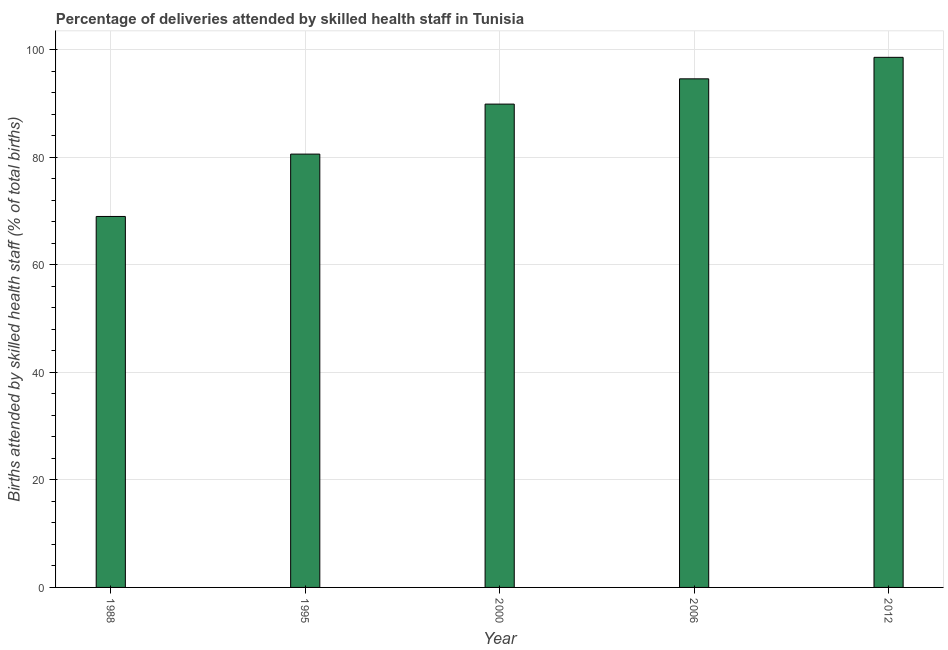What is the title of the graph?
Your answer should be very brief. Percentage of deliveries attended by skilled health staff in Tunisia. What is the label or title of the X-axis?
Your response must be concise. Year. What is the label or title of the Y-axis?
Ensure brevity in your answer.  Births attended by skilled health staff (% of total births). What is the number of births attended by skilled health staff in 2000?
Offer a terse response. 89.9. Across all years, what is the maximum number of births attended by skilled health staff?
Your response must be concise. 98.6. Across all years, what is the minimum number of births attended by skilled health staff?
Your response must be concise. 69. What is the sum of the number of births attended by skilled health staff?
Your answer should be very brief. 432.7. What is the difference between the number of births attended by skilled health staff in 1988 and 2000?
Make the answer very short. -20.9. What is the average number of births attended by skilled health staff per year?
Give a very brief answer. 86.54. What is the median number of births attended by skilled health staff?
Provide a succinct answer. 89.9. In how many years, is the number of births attended by skilled health staff greater than 32 %?
Your answer should be compact. 5. What is the ratio of the number of births attended by skilled health staff in 1988 to that in 2000?
Your answer should be very brief. 0.77. What is the difference between the highest and the second highest number of births attended by skilled health staff?
Your answer should be very brief. 4. Is the sum of the number of births attended by skilled health staff in 1995 and 2006 greater than the maximum number of births attended by skilled health staff across all years?
Your answer should be compact. Yes. What is the difference between the highest and the lowest number of births attended by skilled health staff?
Ensure brevity in your answer.  29.6. How many bars are there?
Provide a short and direct response. 5. How many years are there in the graph?
Offer a very short reply. 5. What is the Births attended by skilled health staff (% of total births) of 1995?
Give a very brief answer. 80.6. What is the Births attended by skilled health staff (% of total births) in 2000?
Keep it short and to the point. 89.9. What is the Births attended by skilled health staff (% of total births) in 2006?
Your response must be concise. 94.6. What is the Births attended by skilled health staff (% of total births) in 2012?
Your answer should be very brief. 98.6. What is the difference between the Births attended by skilled health staff (% of total births) in 1988 and 1995?
Your answer should be compact. -11.6. What is the difference between the Births attended by skilled health staff (% of total births) in 1988 and 2000?
Give a very brief answer. -20.9. What is the difference between the Births attended by skilled health staff (% of total births) in 1988 and 2006?
Ensure brevity in your answer.  -25.6. What is the difference between the Births attended by skilled health staff (% of total births) in 1988 and 2012?
Give a very brief answer. -29.6. What is the difference between the Births attended by skilled health staff (% of total births) in 1995 and 2012?
Offer a very short reply. -18. What is the ratio of the Births attended by skilled health staff (% of total births) in 1988 to that in 1995?
Your answer should be very brief. 0.86. What is the ratio of the Births attended by skilled health staff (% of total births) in 1988 to that in 2000?
Provide a succinct answer. 0.77. What is the ratio of the Births attended by skilled health staff (% of total births) in 1988 to that in 2006?
Ensure brevity in your answer.  0.73. What is the ratio of the Births attended by skilled health staff (% of total births) in 1995 to that in 2000?
Your answer should be compact. 0.9. What is the ratio of the Births attended by skilled health staff (% of total births) in 1995 to that in 2006?
Offer a very short reply. 0.85. What is the ratio of the Births attended by skilled health staff (% of total births) in 1995 to that in 2012?
Make the answer very short. 0.82. What is the ratio of the Births attended by skilled health staff (% of total births) in 2000 to that in 2006?
Your answer should be very brief. 0.95. What is the ratio of the Births attended by skilled health staff (% of total births) in 2000 to that in 2012?
Offer a terse response. 0.91. 